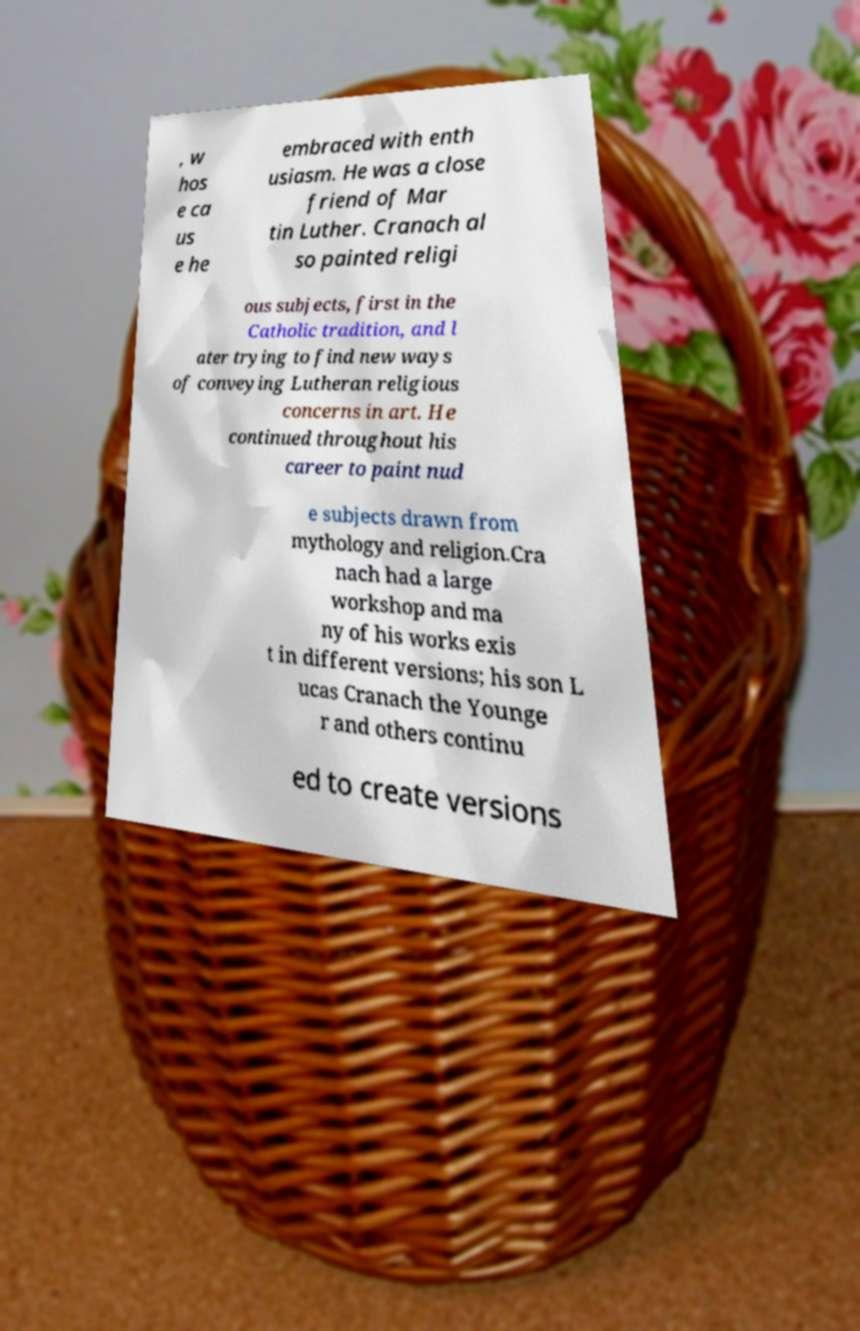Could you assist in decoding the text presented in this image and type it out clearly? , w hos e ca us e he embraced with enth usiasm. He was a close friend of Mar tin Luther. Cranach al so painted religi ous subjects, first in the Catholic tradition, and l ater trying to find new ways of conveying Lutheran religious concerns in art. He continued throughout his career to paint nud e subjects drawn from mythology and religion.Cra nach had a large workshop and ma ny of his works exis t in different versions; his son L ucas Cranach the Younge r and others continu ed to create versions 